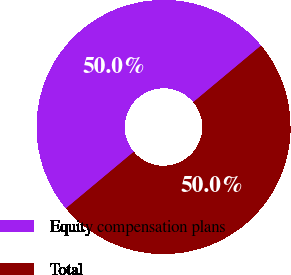<chart> <loc_0><loc_0><loc_500><loc_500><pie_chart><fcel>Equity compensation plans<fcel>Total<nl><fcel>50.0%<fcel>50.0%<nl></chart> 